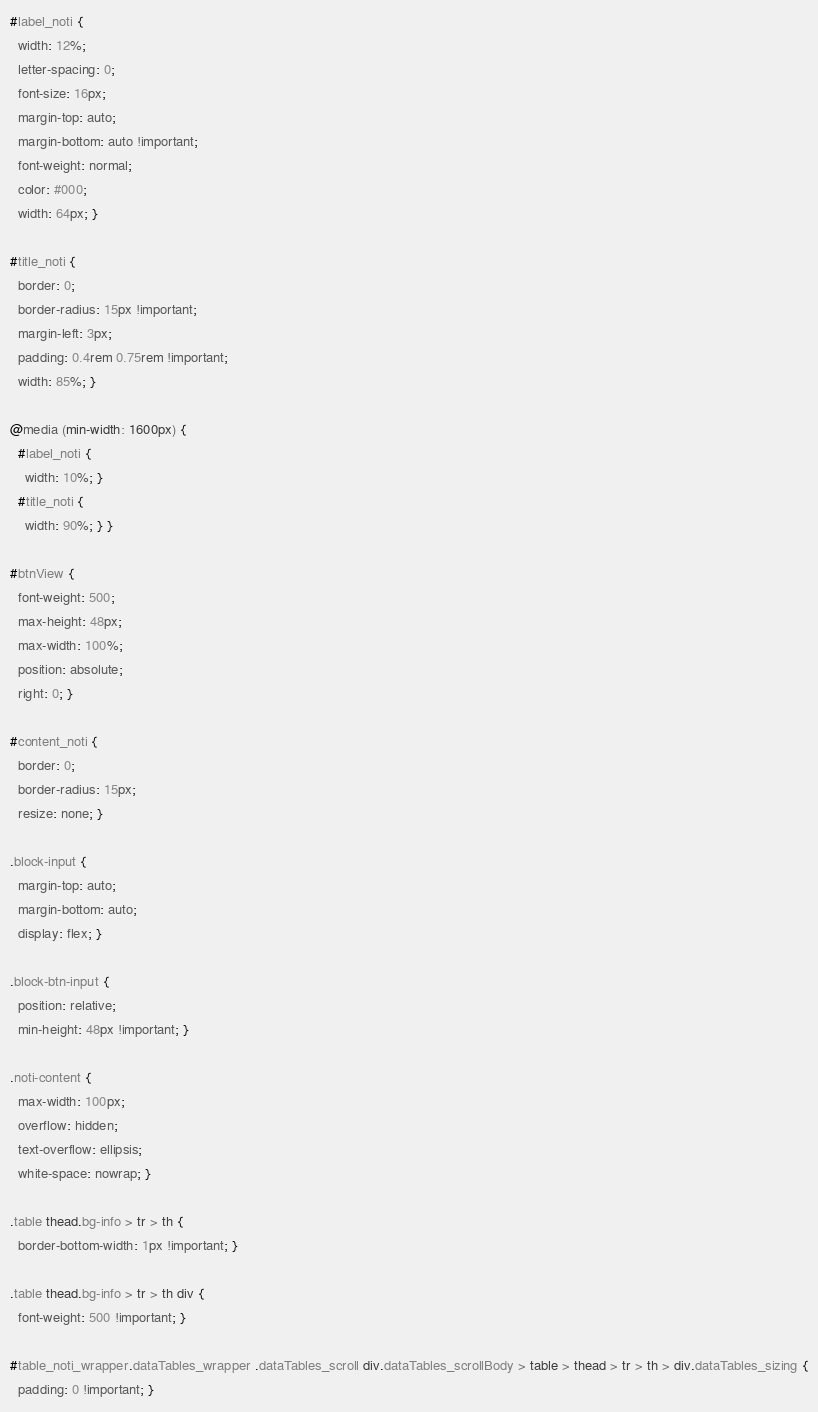Convert code to text. <code><loc_0><loc_0><loc_500><loc_500><_CSS_>#label_noti {
  width: 12%;
  letter-spacing: 0;
  font-size: 16px;
  margin-top: auto;
  margin-bottom: auto !important;
  font-weight: normal;
  color: #000;
  width: 64px; }

#title_noti {
  border: 0;
  border-radius: 15px !important;
  margin-left: 3px;
  padding: 0.4rem 0.75rem !important;
  width: 85%; }

@media (min-width: 1600px) {
  #label_noti {
    width: 10%; }
  #title_noti {
    width: 90%; } }

#btnView {
  font-weight: 500;
  max-height: 48px;
  max-width: 100%;
  position: absolute;
  right: 0; }

#content_noti {
  border: 0;
  border-radius: 15px;
  resize: none; }

.block-input {
  margin-top: auto;
  margin-bottom: auto;
  display: flex; }

.block-btn-input {
  position: relative;
  min-height: 48px !important; }

.noti-content {
  max-width: 100px;
  overflow: hidden;
  text-overflow: ellipsis;
  white-space: nowrap; }

.table thead.bg-info > tr > th {
  border-bottom-width: 1px !important; }

.table thead.bg-info > tr > th div {
  font-weight: 500 !important; }

#table_noti_wrapper.dataTables_wrapper .dataTables_scroll div.dataTables_scrollBody > table > thead > tr > th > div.dataTables_sizing {
  padding: 0 !important; }
</code> 